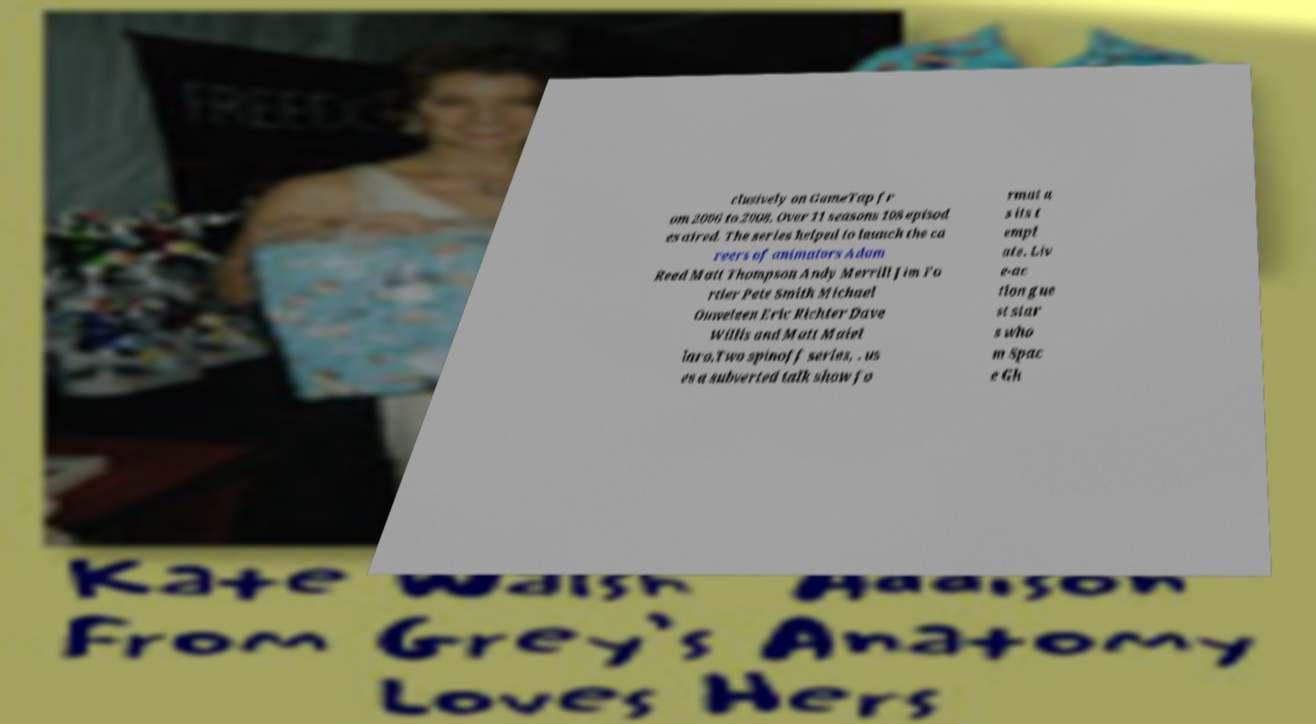I need the written content from this picture converted into text. Can you do that? clusively on GameTap fr om 2006 to 2008. Over 11 seasons 108 episod es aired. The series helped to launch the ca reers of animators Adam Reed Matt Thompson Andy Merrill Jim Fo rtier Pete Smith Michael Ouweleen Eric Richter Dave Willis and Matt Maiel laro.Two spinoff series, . us es a subverted talk show fo rmat a s its t empl ate. Liv e-ac tion gue st star s who m Spac e Gh 